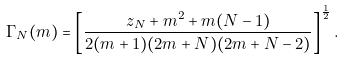Convert formula to latex. <formula><loc_0><loc_0><loc_500><loc_500>\Gamma _ { N } ( m ) = \left [ \frac { z _ { N } + m ^ { 2 } + m ( N - 1 ) } { 2 ( m + 1 ) ( 2 m + N ) ( 2 m + N - 2 ) } \right ] ^ { \frac { 1 } { 2 } } .</formula> 